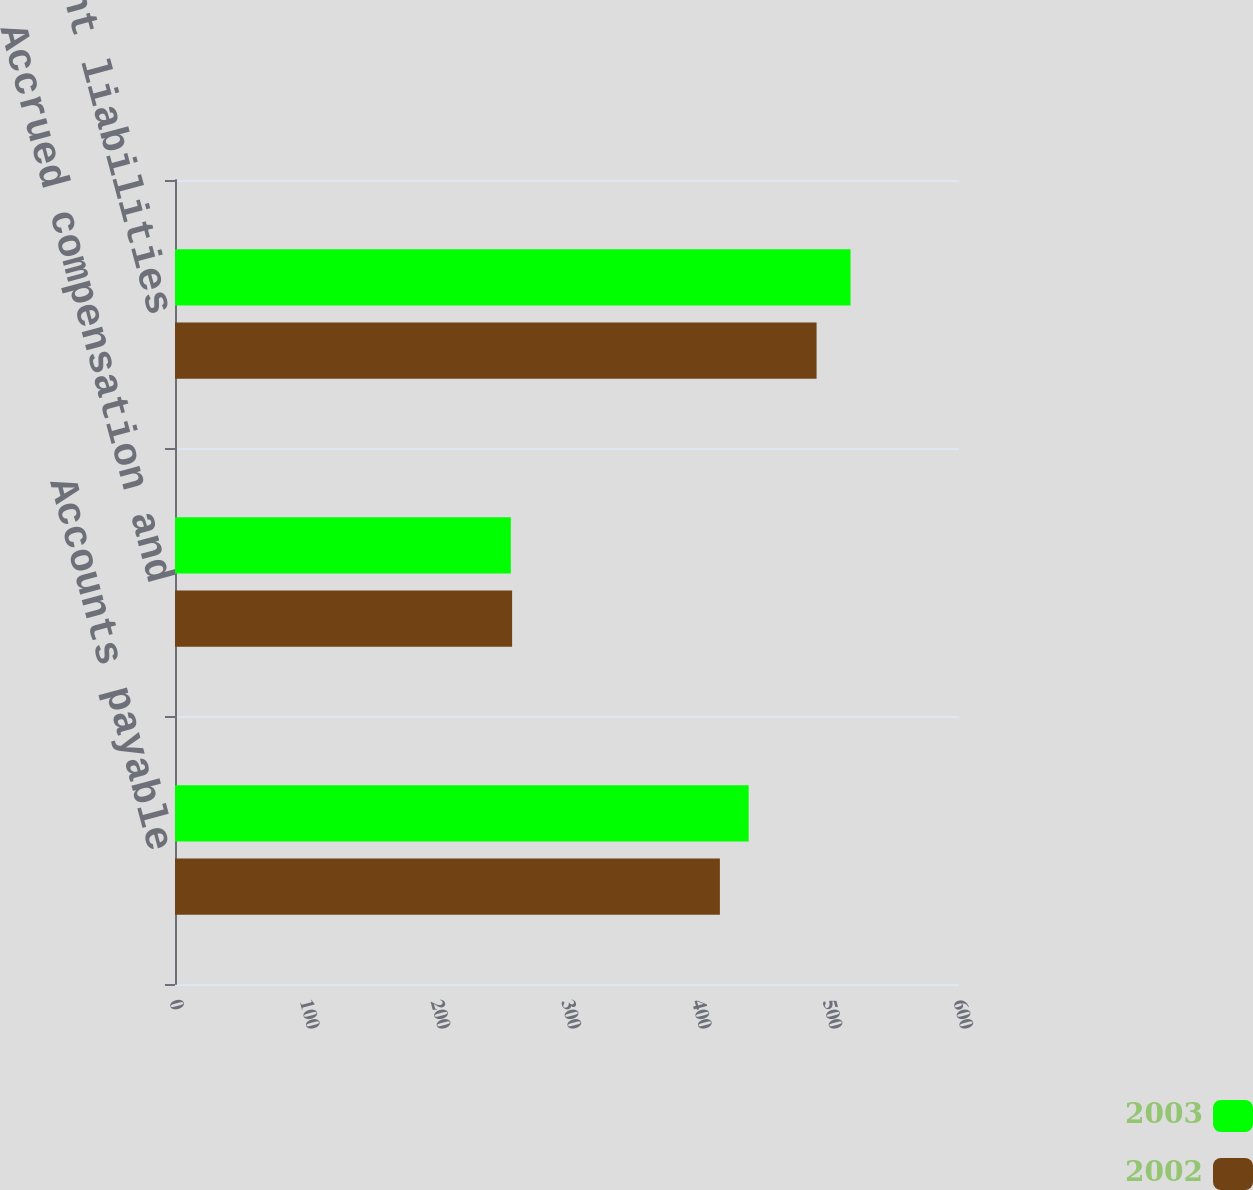Convert chart to OTSL. <chart><loc_0><loc_0><loc_500><loc_500><stacked_bar_chart><ecel><fcel>Accounts payable<fcel>Accrued compensation and<fcel>Other current liabilities<nl><fcel>2003<fcel>439<fcel>257<fcel>517<nl><fcel>2002<fcel>417<fcel>258<fcel>491<nl></chart> 